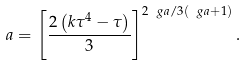<formula> <loc_0><loc_0><loc_500><loc_500>a = \left [ \frac { 2 \left ( k \tau ^ { 4 } - \tau \right ) } { 3 } \right ] ^ { 2 \ g a / 3 ( \ g a + 1 ) } .</formula> 